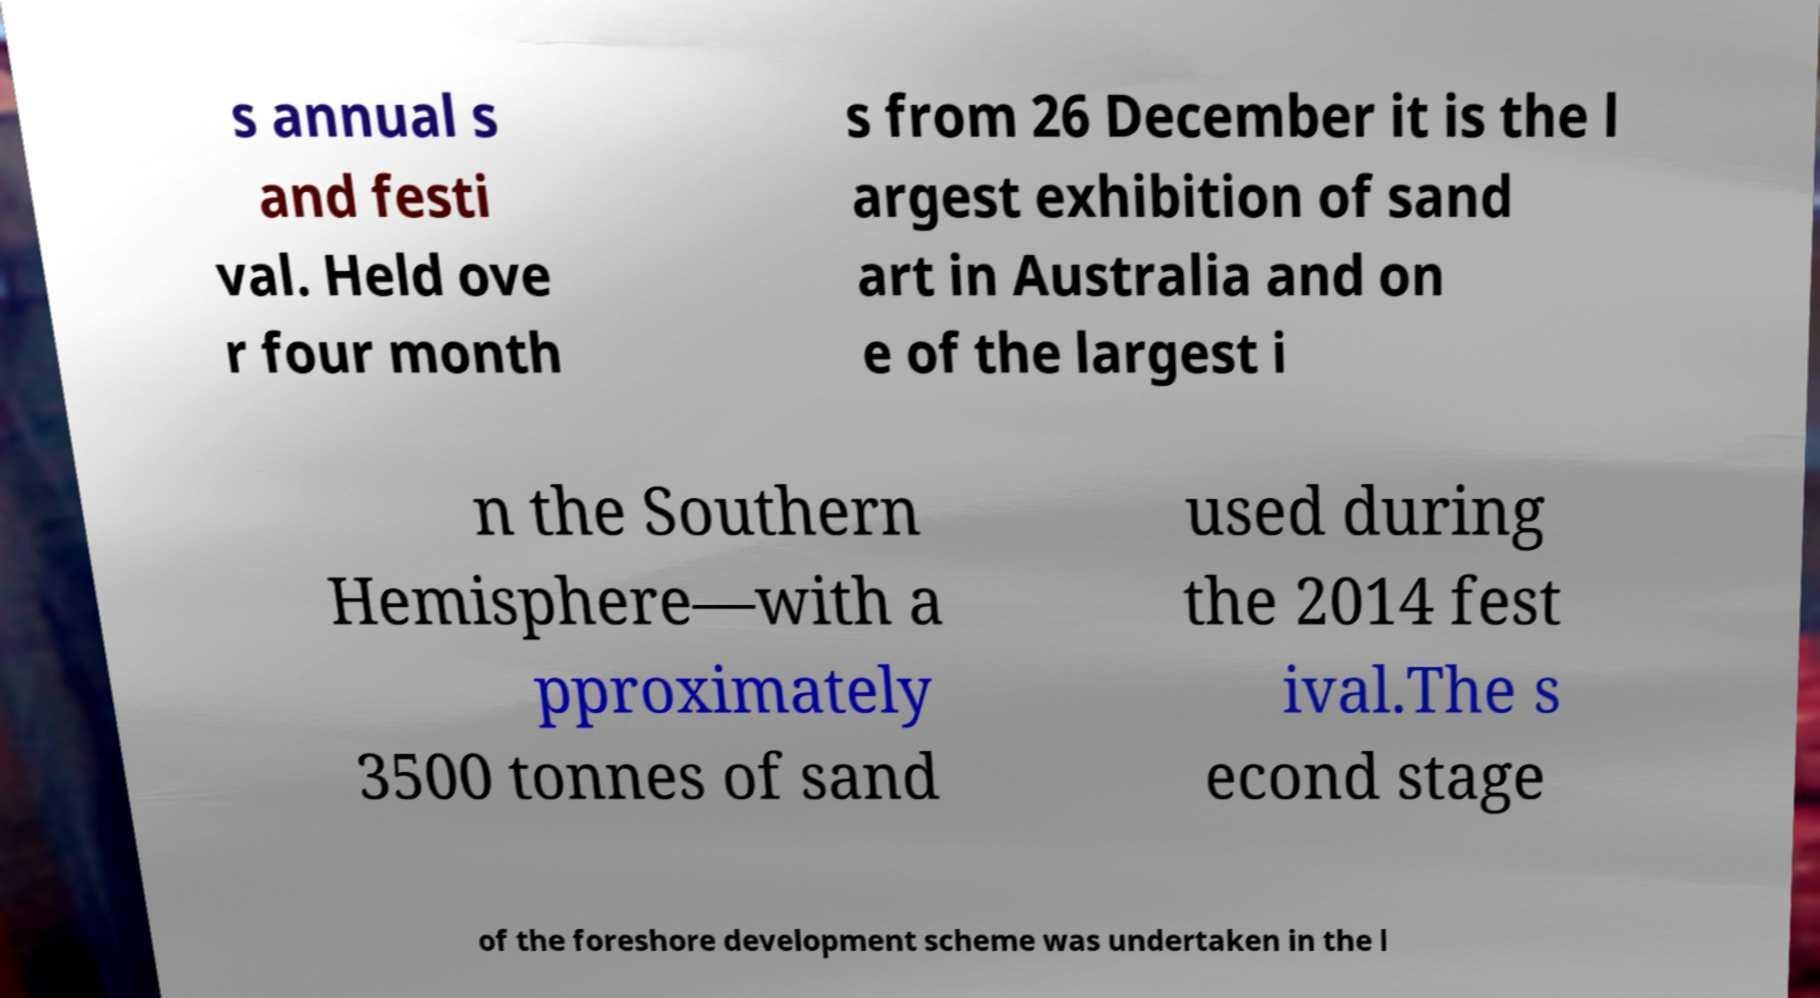Can you accurately transcribe the text from the provided image for me? s annual s and festi val. Held ove r four month s from 26 December it is the l argest exhibition of sand art in Australia and on e of the largest i n the Southern Hemisphere—with a pproximately 3500 tonnes of sand used during the 2014 fest ival.The s econd stage of the foreshore development scheme was undertaken in the l 